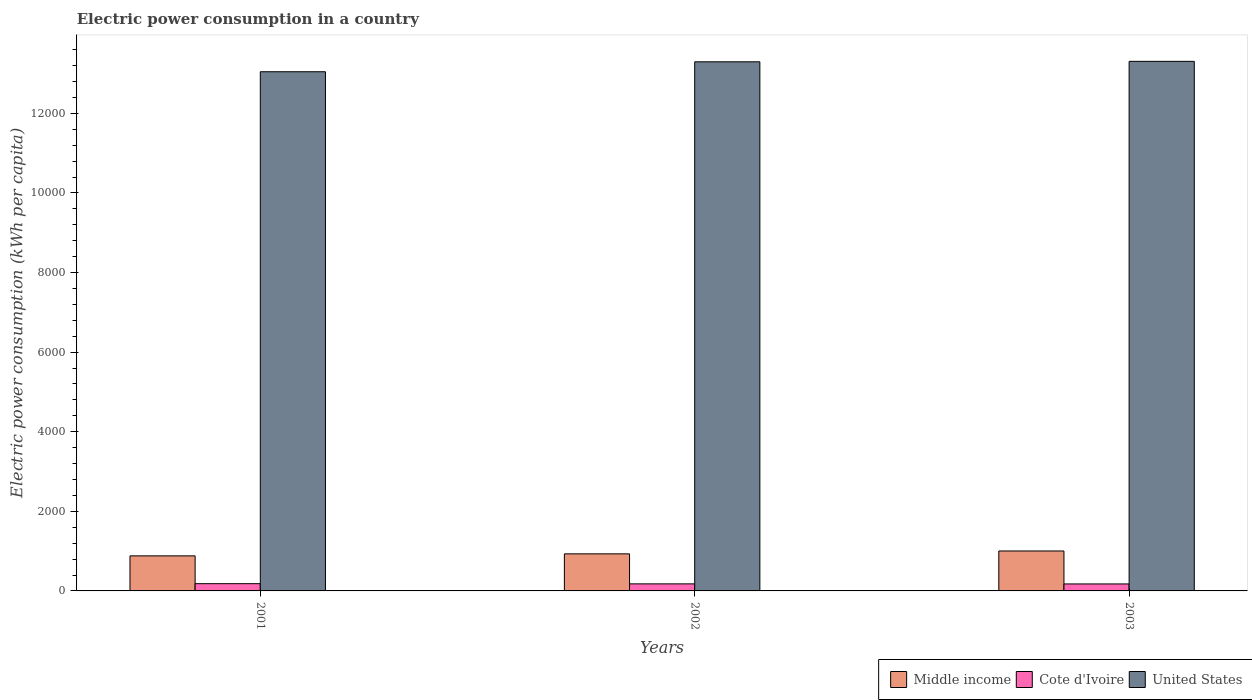How many different coloured bars are there?
Your response must be concise. 3. Are the number of bars on each tick of the X-axis equal?
Your answer should be very brief. Yes. What is the label of the 3rd group of bars from the left?
Provide a succinct answer. 2003. In how many cases, is the number of bars for a given year not equal to the number of legend labels?
Provide a short and direct response. 0. What is the electric power consumption in in Middle income in 2002?
Provide a succinct answer. 931.47. Across all years, what is the maximum electric power consumption in in Cote d'Ivoire?
Ensure brevity in your answer.  182.09. Across all years, what is the minimum electric power consumption in in Cote d'Ivoire?
Your answer should be compact. 175.46. In which year was the electric power consumption in in Cote d'Ivoire minimum?
Give a very brief answer. 2003. What is the total electric power consumption in in Cote d'Ivoire in the graph?
Provide a succinct answer. 534.67. What is the difference between the electric power consumption in in Cote d'Ivoire in 2002 and that in 2003?
Give a very brief answer. 1.67. What is the difference between the electric power consumption in in United States in 2003 and the electric power consumption in in Middle income in 2002?
Keep it short and to the point. 1.24e+04. What is the average electric power consumption in in United States per year?
Your response must be concise. 1.32e+04. In the year 2002, what is the difference between the electric power consumption in in Cote d'Ivoire and electric power consumption in in Middle income?
Your answer should be compact. -754.34. What is the ratio of the electric power consumption in in Middle income in 2002 to that in 2003?
Provide a short and direct response. 0.93. Is the electric power consumption in in Cote d'Ivoire in 2001 less than that in 2003?
Your answer should be compact. No. What is the difference between the highest and the second highest electric power consumption in in United States?
Provide a succinct answer. 11.31. What is the difference between the highest and the lowest electric power consumption in in United States?
Your answer should be compact. 260.88. In how many years, is the electric power consumption in in Middle income greater than the average electric power consumption in in Middle income taken over all years?
Provide a succinct answer. 1. What does the 1st bar from the right in 2002 represents?
Provide a succinct answer. United States. How many bars are there?
Give a very brief answer. 9. What is the difference between two consecutive major ticks on the Y-axis?
Offer a terse response. 2000. Does the graph contain any zero values?
Your response must be concise. No. Does the graph contain grids?
Your answer should be very brief. No. Where does the legend appear in the graph?
Give a very brief answer. Bottom right. How many legend labels are there?
Keep it short and to the point. 3. What is the title of the graph?
Make the answer very short. Electric power consumption in a country. What is the label or title of the Y-axis?
Your response must be concise. Electric power consumption (kWh per capita). What is the Electric power consumption (kWh per capita) of Middle income in 2001?
Your answer should be very brief. 881.06. What is the Electric power consumption (kWh per capita) in Cote d'Ivoire in 2001?
Your answer should be compact. 182.09. What is the Electric power consumption (kWh per capita) of United States in 2001?
Your answer should be very brief. 1.30e+04. What is the Electric power consumption (kWh per capita) in Middle income in 2002?
Offer a very short reply. 931.47. What is the Electric power consumption (kWh per capita) of Cote d'Ivoire in 2002?
Offer a very short reply. 177.13. What is the Electric power consumption (kWh per capita) in United States in 2002?
Your response must be concise. 1.33e+04. What is the Electric power consumption (kWh per capita) in Middle income in 2003?
Provide a short and direct response. 1003.65. What is the Electric power consumption (kWh per capita) in Cote d'Ivoire in 2003?
Give a very brief answer. 175.46. What is the Electric power consumption (kWh per capita) in United States in 2003?
Offer a very short reply. 1.33e+04. Across all years, what is the maximum Electric power consumption (kWh per capita) in Middle income?
Provide a short and direct response. 1003.65. Across all years, what is the maximum Electric power consumption (kWh per capita) in Cote d'Ivoire?
Offer a very short reply. 182.09. Across all years, what is the maximum Electric power consumption (kWh per capita) in United States?
Provide a succinct answer. 1.33e+04. Across all years, what is the minimum Electric power consumption (kWh per capita) in Middle income?
Provide a short and direct response. 881.06. Across all years, what is the minimum Electric power consumption (kWh per capita) of Cote d'Ivoire?
Provide a succinct answer. 175.46. Across all years, what is the minimum Electric power consumption (kWh per capita) in United States?
Your response must be concise. 1.30e+04. What is the total Electric power consumption (kWh per capita) of Middle income in the graph?
Make the answer very short. 2816.17. What is the total Electric power consumption (kWh per capita) of Cote d'Ivoire in the graph?
Ensure brevity in your answer.  534.67. What is the total Electric power consumption (kWh per capita) of United States in the graph?
Provide a short and direct response. 3.97e+04. What is the difference between the Electric power consumption (kWh per capita) of Middle income in 2001 and that in 2002?
Keep it short and to the point. -50.41. What is the difference between the Electric power consumption (kWh per capita) of Cote d'Ivoire in 2001 and that in 2002?
Provide a short and direct response. 4.96. What is the difference between the Electric power consumption (kWh per capita) of United States in 2001 and that in 2002?
Keep it short and to the point. -249.57. What is the difference between the Electric power consumption (kWh per capita) in Middle income in 2001 and that in 2003?
Ensure brevity in your answer.  -122.59. What is the difference between the Electric power consumption (kWh per capita) of Cote d'Ivoire in 2001 and that in 2003?
Your answer should be very brief. 6.63. What is the difference between the Electric power consumption (kWh per capita) of United States in 2001 and that in 2003?
Ensure brevity in your answer.  -260.88. What is the difference between the Electric power consumption (kWh per capita) of Middle income in 2002 and that in 2003?
Ensure brevity in your answer.  -72.18. What is the difference between the Electric power consumption (kWh per capita) of Cote d'Ivoire in 2002 and that in 2003?
Keep it short and to the point. 1.67. What is the difference between the Electric power consumption (kWh per capita) in United States in 2002 and that in 2003?
Give a very brief answer. -11.31. What is the difference between the Electric power consumption (kWh per capita) in Middle income in 2001 and the Electric power consumption (kWh per capita) in Cote d'Ivoire in 2002?
Ensure brevity in your answer.  703.93. What is the difference between the Electric power consumption (kWh per capita) in Middle income in 2001 and the Electric power consumption (kWh per capita) in United States in 2002?
Offer a very short reply. -1.24e+04. What is the difference between the Electric power consumption (kWh per capita) in Cote d'Ivoire in 2001 and the Electric power consumption (kWh per capita) in United States in 2002?
Offer a very short reply. -1.31e+04. What is the difference between the Electric power consumption (kWh per capita) of Middle income in 2001 and the Electric power consumption (kWh per capita) of Cote d'Ivoire in 2003?
Keep it short and to the point. 705.6. What is the difference between the Electric power consumption (kWh per capita) of Middle income in 2001 and the Electric power consumption (kWh per capita) of United States in 2003?
Keep it short and to the point. -1.24e+04. What is the difference between the Electric power consumption (kWh per capita) in Cote d'Ivoire in 2001 and the Electric power consumption (kWh per capita) in United States in 2003?
Provide a short and direct response. -1.31e+04. What is the difference between the Electric power consumption (kWh per capita) of Middle income in 2002 and the Electric power consumption (kWh per capita) of Cote d'Ivoire in 2003?
Your answer should be compact. 756.01. What is the difference between the Electric power consumption (kWh per capita) of Middle income in 2002 and the Electric power consumption (kWh per capita) of United States in 2003?
Your response must be concise. -1.24e+04. What is the difference between the Electric power consumption (kWh per capita) of Cote d'Ivoire in 2002 and the Electric power consumption (kWh per capita) of United States in 2003?
Provide a short and direct response. -1.31e+04. What is the average Electric power consumption (kWh per capita) in Middle income per year?
Keep it short and to the point. 938.72. What is the average Electric power consumption (kWh per capita) in Cote d'Ivoire per year?
Offer a terse response. 178.22. What is the average Electric power consumption (kWh per capita) of United States per year?
Make the answer very short. 1.32e+04. In the year 2001, what is the difference between the Electric power consumption (kWh per capita) of Middle income and Electric power consumption (kWh per capita) of Cote d'Ivoire?
Offer a terse response. 698.97. In the year 2001, what is the difference between the Electric power consumption (kWh per capita) in Middle income and Electric power consumption (kWh per capita) in United States?
Your response must be concise. -1.22e+04. In the year 2001, what is the difference between the Electric power consumption (kWh per capita) of Cote d'Ivoire and Electric power consumption (kWh per capita) of United States?
Ensure brevity in your answer.  -1.29e+04. In the year 2002, what is the difference between the Electric power consumption (kWh per capita) of Middle income and Electric power consumption (kWh per capita) of Cote d'Ivoire?
Your answer should be very brief. 754.34. In the year 2002, what is the difference between the Electric power consumption (kWh per capita) of Middle income and Electric power consumption (kWh per capita) of United States?
Offer a very short reply. -1.24e+04. In the year 2002, what is the difference between the Electric power consumption (kWh per capita) of Cote d'Ivoire and Electric power consumption (kWh per capita) of United States?
Give a very brief answer. -1.31e+04. In the year 2003, what is the difference between the Electric power consumption (kWh per capita) in Middle income and Electric power consumption (kWh per capita) in Cote d'Ivoire?
Offer a very short reply. 828.19. In the year 2003, what is the difference between the Electric power consumption (kWh per capita) in Middle income and Electric power consumption (kWh per capita) in United States?
Provide a short and direct response. -1.23e+04. In the year 2003, what is the difference between the Electric power consumption (kWh per capita) of Cote d'Ivoire and Electric power consumption (kWh per capita) of United States?
Your answer should be very brief. -1.31e+04. What is the ratio of the Electric power consumption (kWh per capita) of Middle income in 2001 to that in 2002?
Your answer should be very brief. 0.95. What is the ratio of the Electric power consumption (kWh per capita) of Cote d'Ivoire in 2001 to that in 2002?
Ensure brevity in your answer.  1.03. What is the ratio of the Electric power consumption (kWh per capita) in United States in 2001 to that in 2002?
Provide a succinct answer. 0.98. What is the ratio of the Electric power consumption (kWh per capita) of Middle income in 2001 to that in 2003?
Your response must be concise. 0.88. What is the ratio of the Electric power consumption (kWh per capita) in Cote d'Ivoire in 2001 to that in 2003?
Ensure brevity in your answer.  1.04. What is the ratio of the Electric power consumption (kWh per capita) in United States in 2001 to that in 2003?
Make the answer very short. 0.98. What is the ratio of the Electric power consumption (kWh per capita) of Middle income in 2002 to that in 2003?
Offer a very short reply. 0.93. What is the ratio of the Electric power consumption (kWh per capita) in Cote d'Ivoire in 2002 to that in 2003?
Make the answer very short. 1.01. What is the difference between the highest and the second highest Electric power consumption (kWh per capita) of Middle income?
Provide a succinct answer. 72.18. What is the difference between the highest and the second highest Electric power consumption (kWh per capita) in Cote d'Ivoire?
Provide a short and direct response. 4.96. What is the difference between the highest and the second highest Electric power consumption (kWh per capita) in United States?
Offer a terse response. 11.31. What is the difference between the highest and the lowest Electric power consumption (kWh per capita) of Middle income?
Keep it short and to the point. 122.59. What is the difference between the highest and the lowest Electric power consumption (kWh per capita) of Cote d'Ivoire?
Your answer should be compact. 6.63. What is the difference between the highest and the lowest Electric power consumption (kWh per capita) in United States?
Keep it short and to the point. 260.88. 